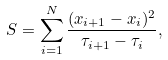Convert formula to latex. <formula><loc_0><loc_0><loc_500><loc_500>S = \sum _ { i = 1 } ^ { N } \frac { ( x _ { i + 1 } - x _ { i } ) ^ { 2 } } { \tau _ { i + 1 } - \tau _ { i } } ,</formula> 